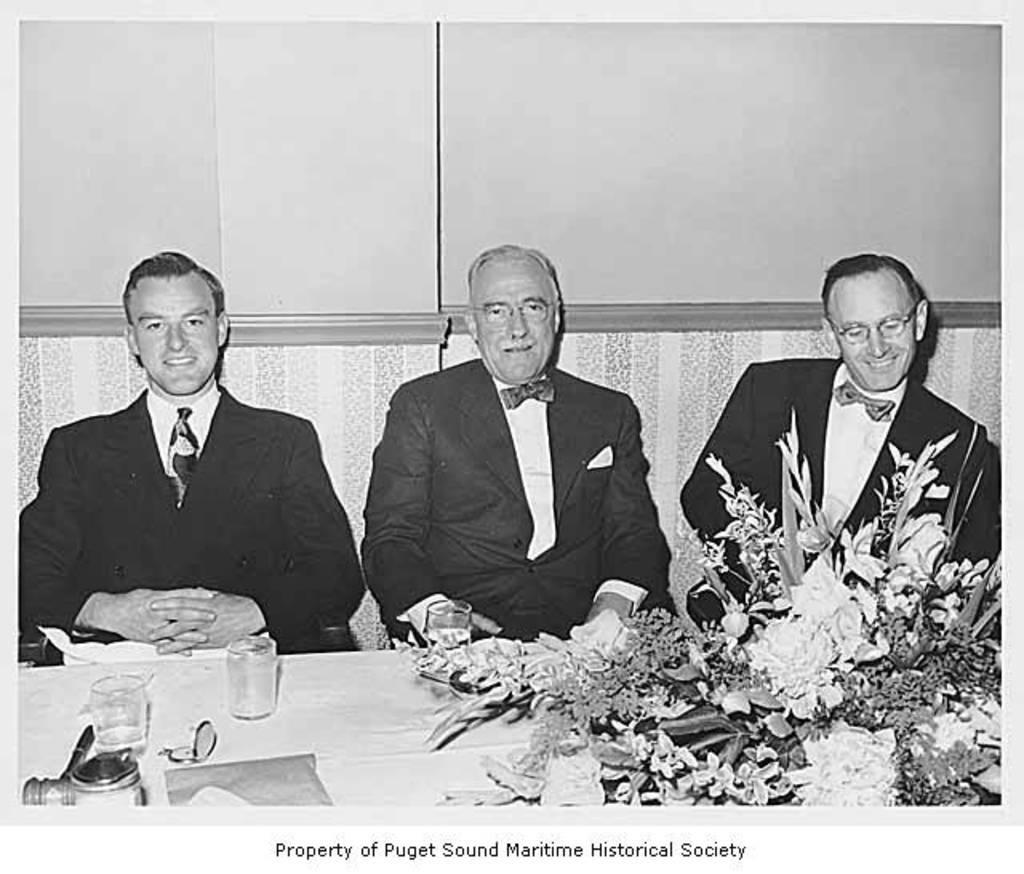Please provide a concise description of this image. This is a black and white image in this image in the center there are three persons, who are sitting and smiling and in front of them there is a table. On the table there are some glasses, bottle and flower bouquet and in the background there is a wall. 